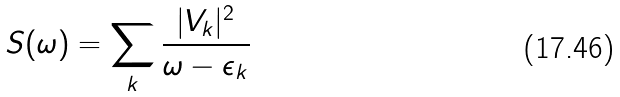Convert formula to latex. <formula><loc_0><loc_0><loc_500><loc_500>S ( \omega ) = \sum _ { k } \frac { | V _ { k } | ^ { 2 } } { \omega - \epsilon _ { k } }</formula> 